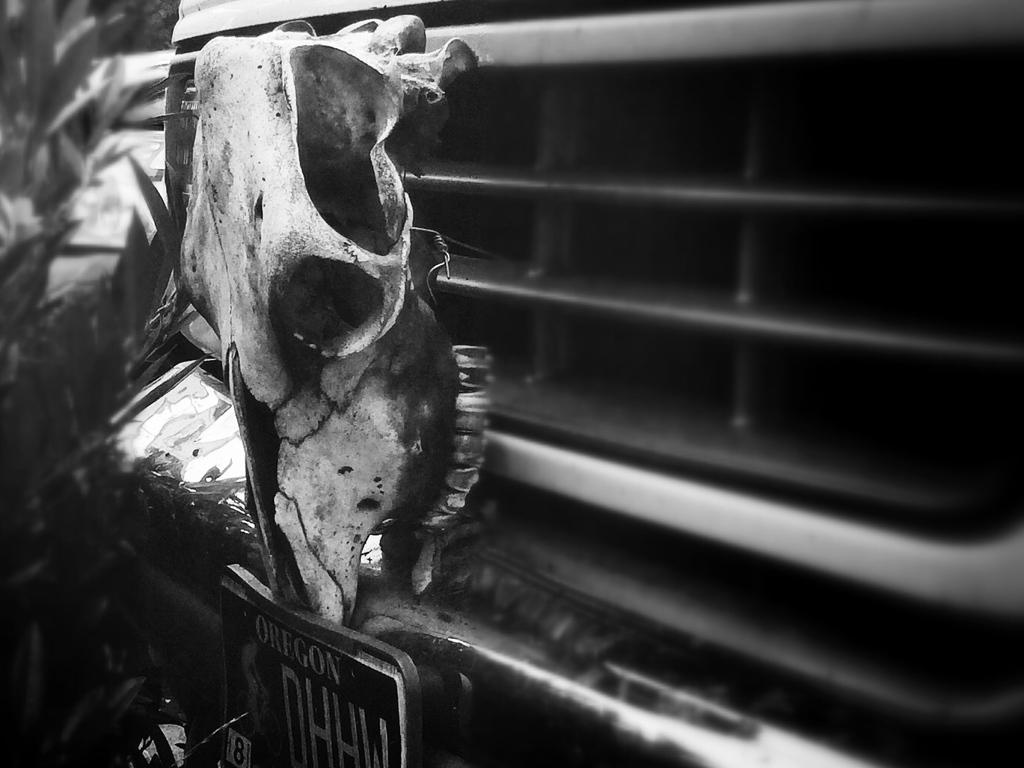What is the color scheme of the image? The image is black and white. What is the main subject of the image? There is a vehicle in the image. How is the vehicle shown in the image? The vehicle is shown from the front. What can be seen on the left side of the image? There are leaves on the left side of the image. How many horses are interacting with the vehicle in the image? There are no horses present in the image; it only features a vehicle and leaves. What type of soap is being used to clean the vehicle in the image? There is no soap or cleaning activity depicted in the image; it only shows a vehicle and leaves. 